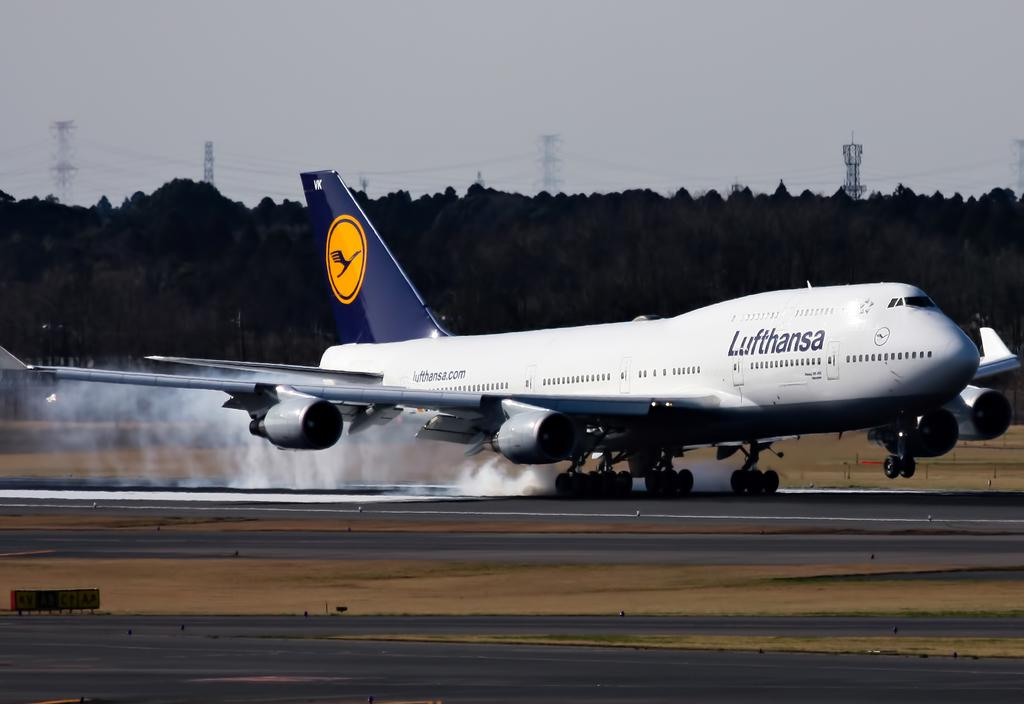Provide a one-sentence caption for the provided image. A commercial airplane has smoke coming out of the back of the plane. 